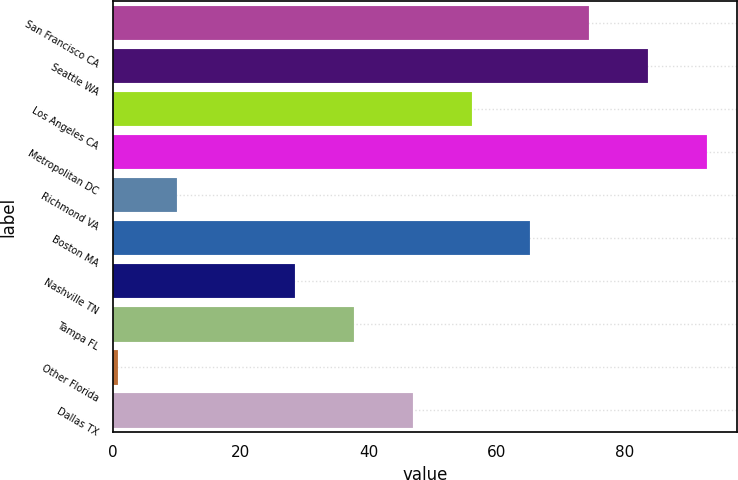Convert chart to OTSL. <chart><loc_0><loc_0><loc_500><loc_500><bar_chart><fcel>San Francisco CA<fcel>Seattle WA<fcel>Los Angeles CA<fcel>Metropolitan DC<fcel>Richmond VA<fcel>Boston MA<fcel>Nashville TN<fcel>Tampa FL<fcel>Other Florida<fcel>Dallas TX<nl><fcel>74.48<fcel>83.69<fcel>56.06<fcel>92.9<fcel>10.01<fcel>65.27<fcel>28.43<fcel>37.64<fcel>0.8<fcel>46.85<nl></chart> 